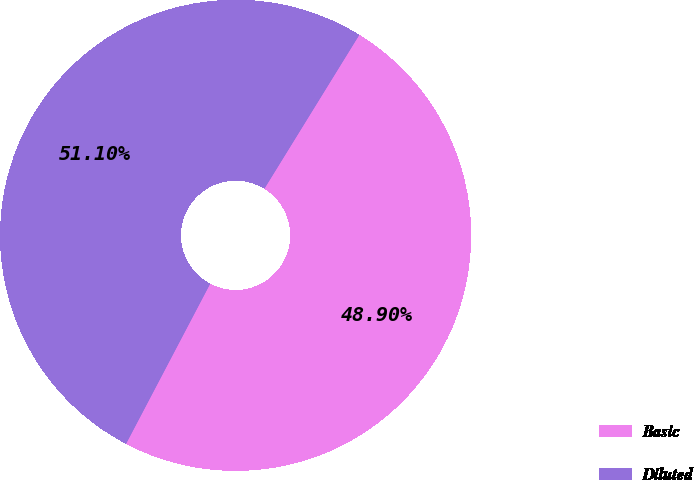Convert chart to OTSL. <chart><loc_0><loc_0><loc_500><loc_500><pie_chart><fcel>Basic<fcel>Diluted<nl><fcel>48.9%<fcel>51.1%<nl></chart> 